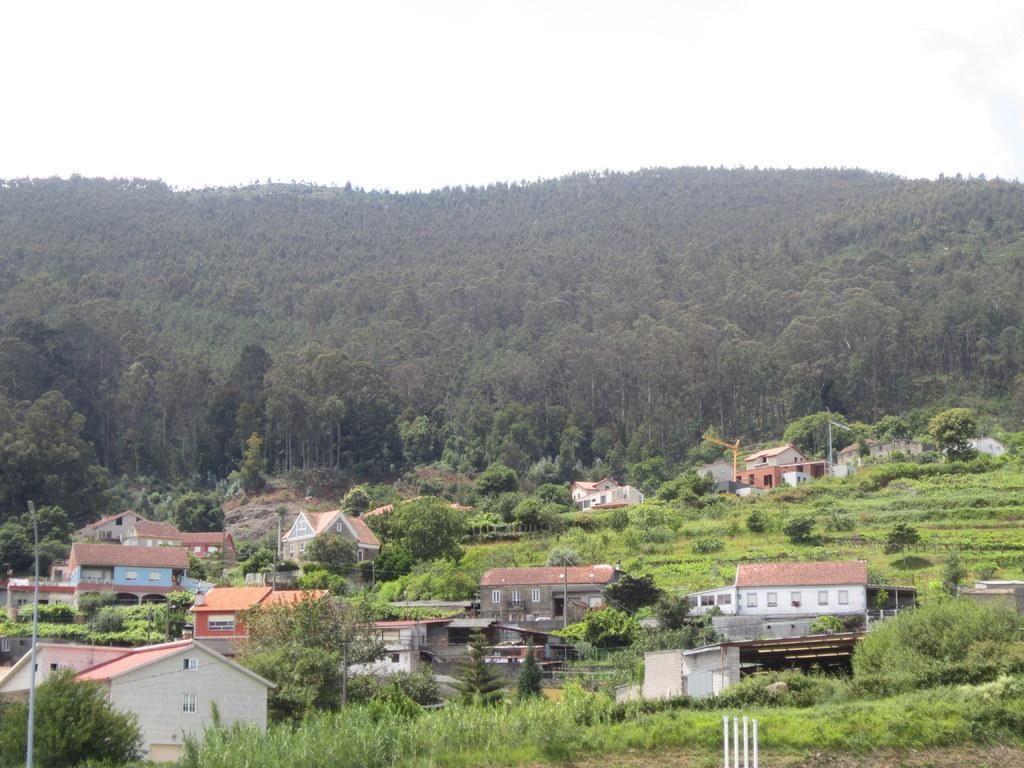In one or two sentences, can you explain what this image depicts? This is the picture of a village. In this picture there are buildings and trees and poles. At the back there are trees on the mountain. At the top there is sky. At the bottom there is grass. 